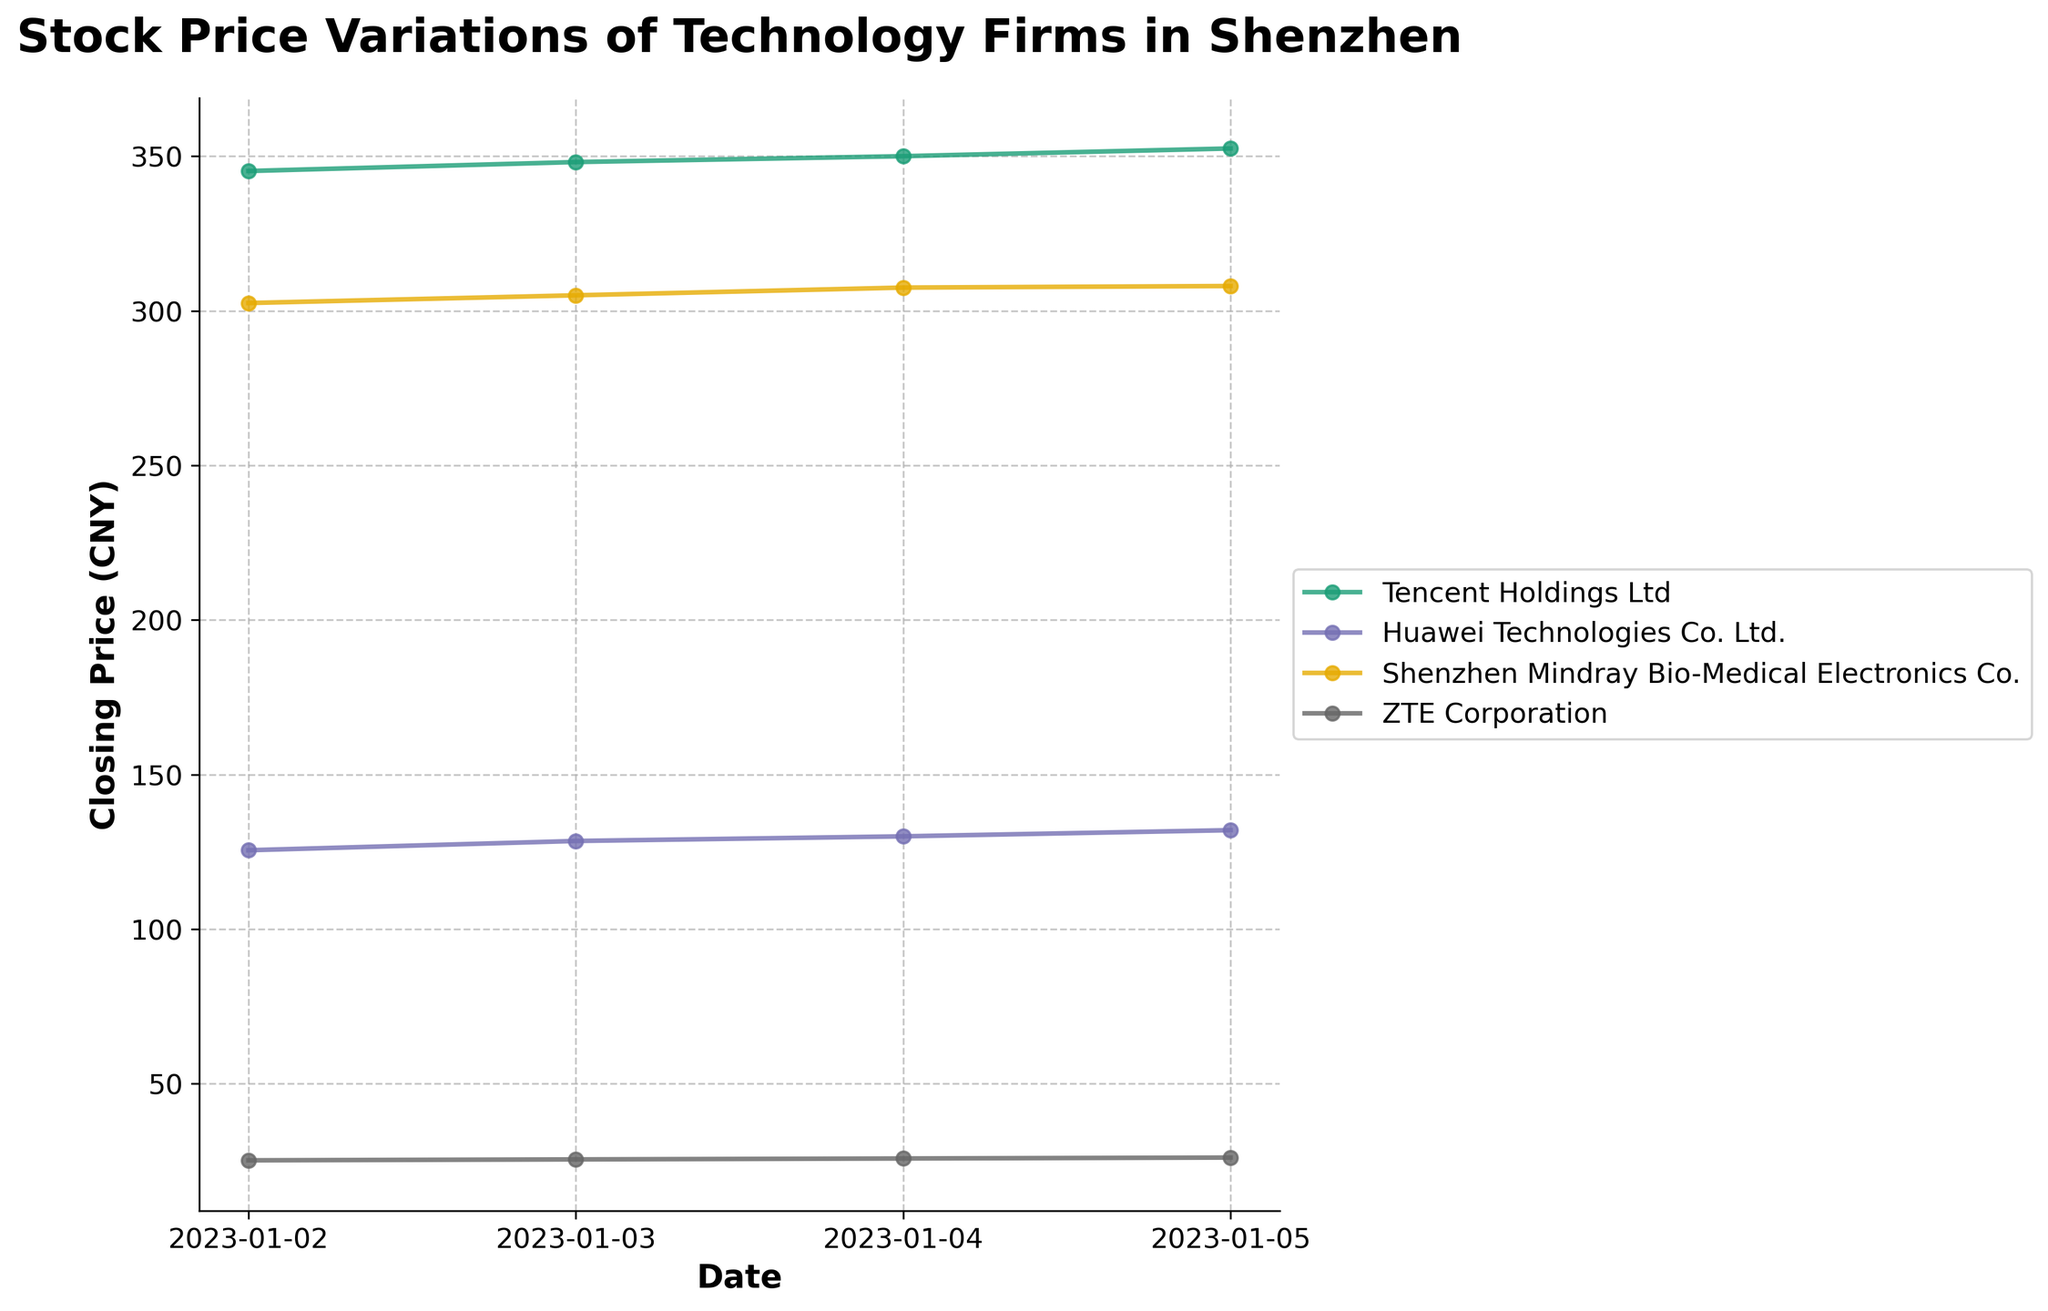What is the title of the plot? The title is written prominently at the top of the plot. It describes the overall content of the plot.
Answer: Stock Price Variations of Technology Firms in Shenzhen Which company had the highest closing price on January 5th, 2023? To find this, look for the closing prices of each company on January 5th and identify the highest one. The plot marks these values clearly.
Answer: Tencent Holdings Ltd What trend is observed in the closing prices of Tencent Holdings Ltd from January 2nd to January 5th, 2023? Look at the line plotted for Tencent Holdings Ltd and observe whether it is increasing, decreasing, or fluctuating over the days specified.
Answer: Increasing trend Calculate the average closing price of ZTE Corporation for the four days presented. Add the closing prices of ZTE Corporation for each of the four days and divide by 4.
Answer: (25.20 + 25.50 + 25.80 + 26.10) / 4 = 25.65 Which company shows the least fluctuation in closing prices over the given dates? Compare how much each company's closing prices vary from day to day by looking at the steepness of their respective lines; the least steep indicates the least fluctuation.
Answer: ZTE Corporation On which date did Huawei Technologies Co. Ltd. have the lowest closing price? Identify the lowest point on the line corresponding to Huawei Technologies Co. Ltd and trace it back to the date axis.
Answer: January 2nd, 2023 Are there any days when the closing prices of all companies decrease compared to the previous day? Check if for any specific day, the closing prices of all companies are lower than those on the previous day. This requires comparing each day's prices against the previous day's.
Answer: No Which company’s closing price had the largest increase from January 4th to January 5th, 2023? Calculate the difference in closing prices between these two dates for each company, and identify the largest increase.
Answer: Huawei Technologies Co. Ltd (132.00 - 130.00 = 2) How does the closing price of Shenzhen Mindray Bio-Medical Electronics Co. on January 5th compare to its opening price on the same day? Look at Shenzhen Mindray Bio-Medical Electronics Co.'s closing and opening prices on January 5th and see which value is higher or if they are equal.
Answer: Slightly higher 